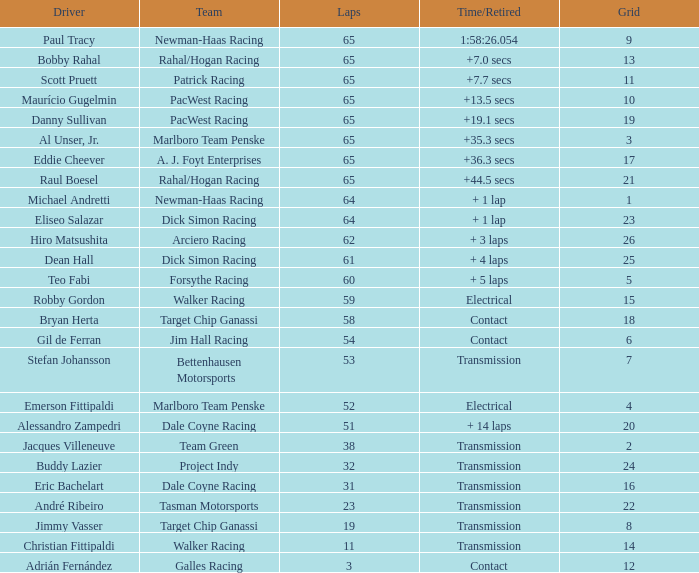What was the highest grid for a time/retired of +19.1 secs? 19.0. 